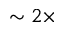<formula> <loc_0><loc_0><loc_500><loc_500>\sim 2 \times</formula> 